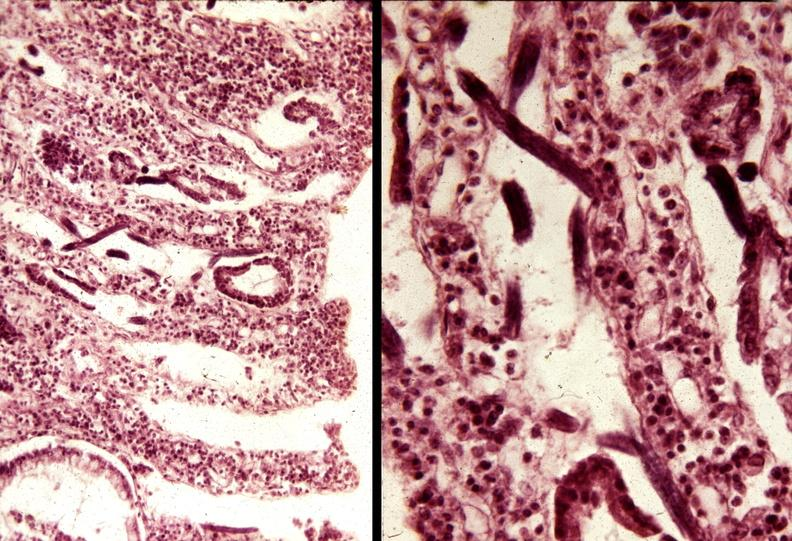does this image show colon, strongyloidiasis?
Answer the question using a single word or phrase. Yes 